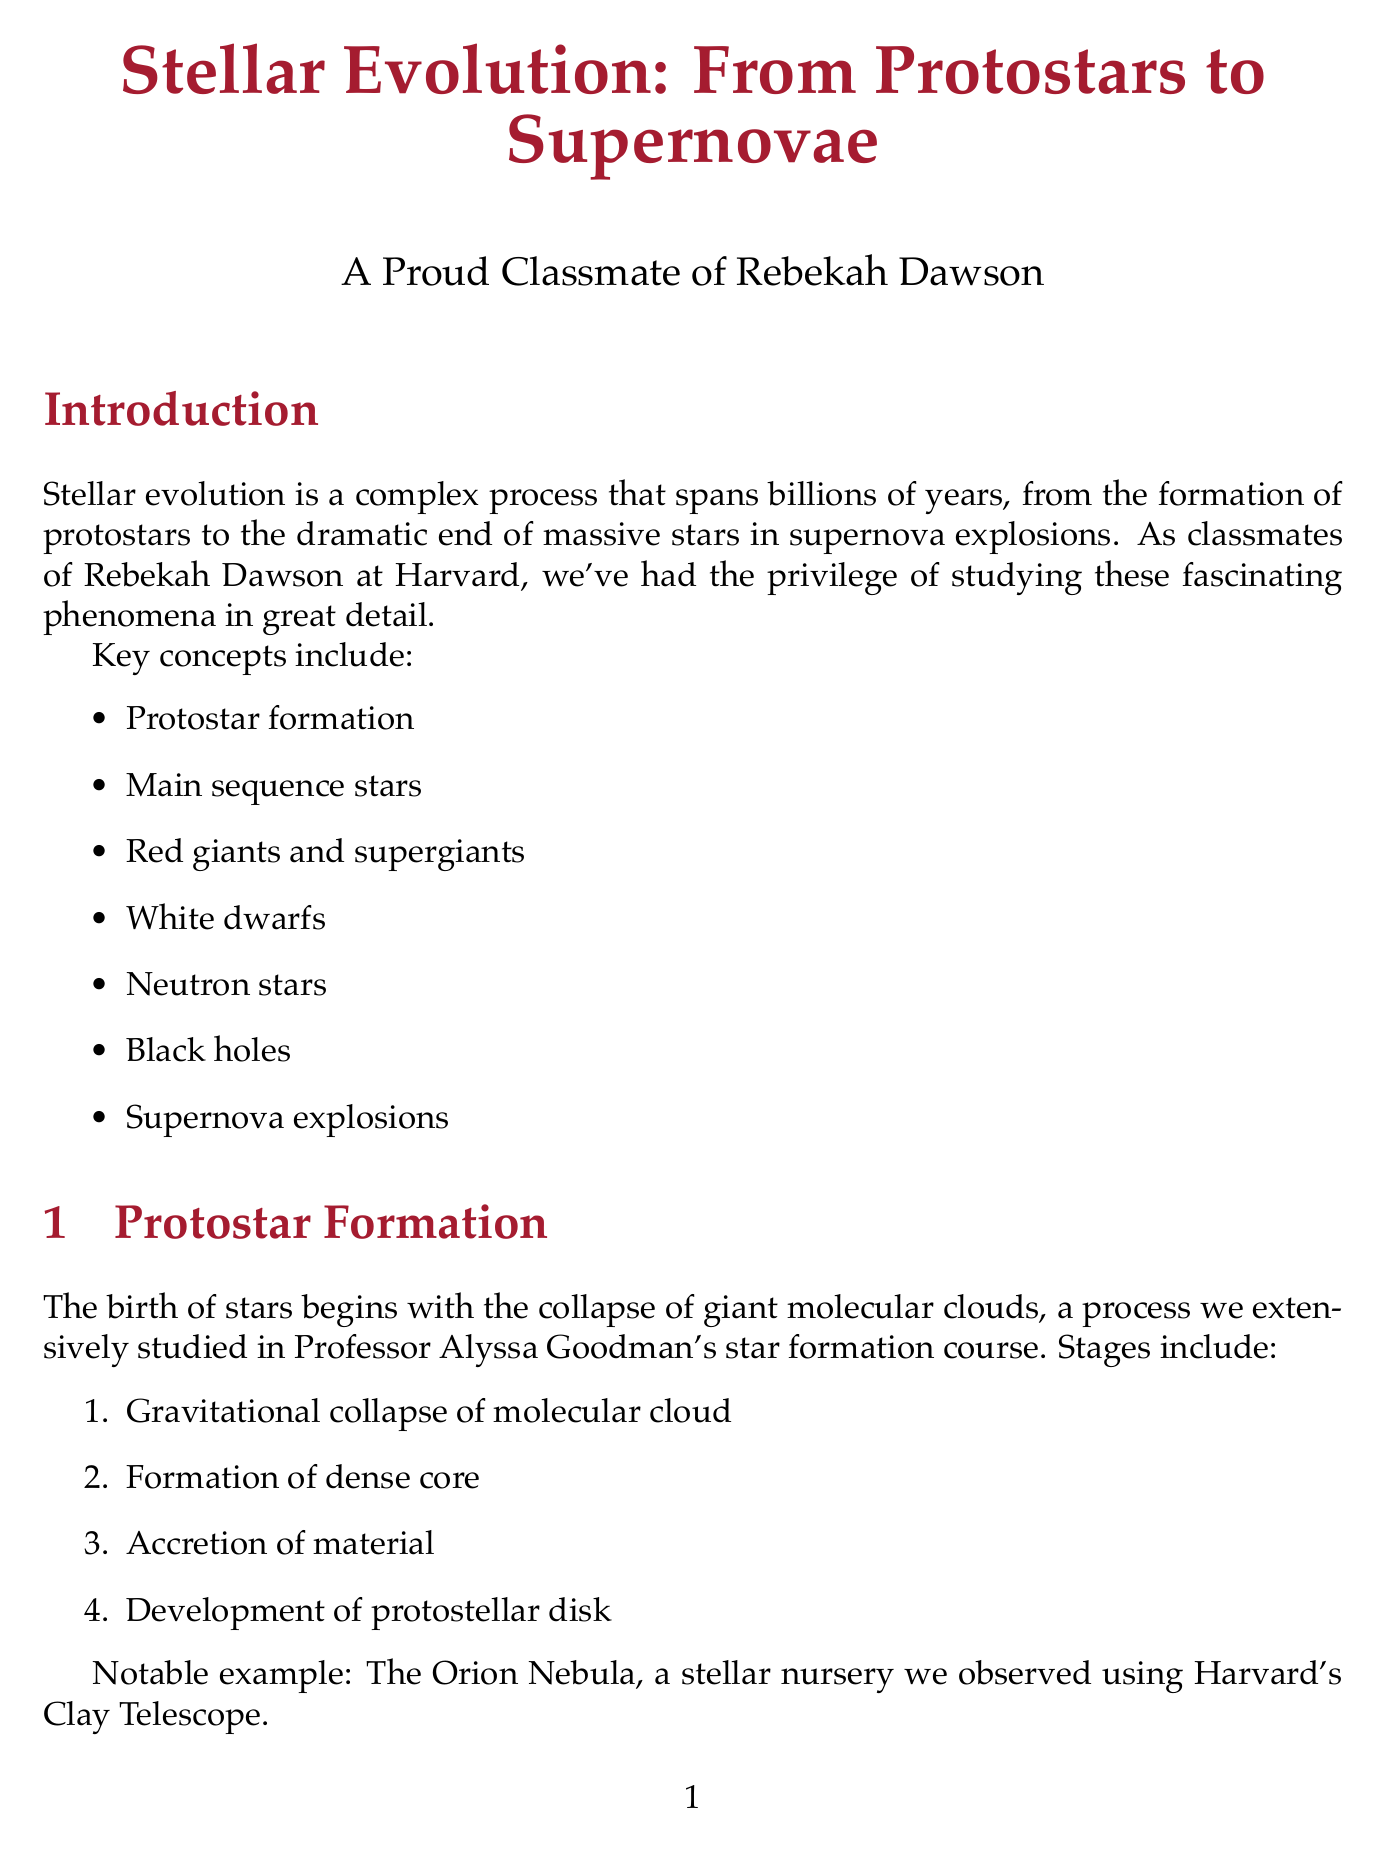What are the key concepts of stellar evolution? The document lists seven key concepts of stellar evolution, which include protostar formation, main sequence stars, red giants and supergiants, white dwarfs, neutron stars, black holes, and supernova explosions.
Answer: Protostar formation, main sequence stars, red giants and supergiants, white dwarfs, neutron stars, black holes, supernova explosions Who explained the red giant phase? The red giant phase was explained by Professor Dimitar Sasselov during his exoplanet course.
Answer: Professor Dimitar Sasselov What is the notable example of a protostar formation mentioned? The document provides the Orion Nebula as a notable example of a stellar nursery where protostar formation occurs.
Answer: The Orion Nebula What are the two types of supernova explosions outlined? The types of supernova explosions mentioned are Type Ia and Type II. These are key points within the supernova explosions section of the report.
Answer: Type Ia, Type II What are the properties of white dwarfs? The document outlines three properties of white dwarfs: electron degeneracy pressure, cooling over time, and the Chandrasekhar limit.
Answer: Electron degeneracy pressure, cooling over time, Chandrasekhar limit What diagram illustrates the stellar luminosity vs. temperature? The Hertzsprung-Russell Diagram is specifically mentioned as illustrating the plot of stellar luminosity vs. temperature.
Answer: Hertzsprung-Russell Diagram Which course did the analysis of main sequence stars use data from? The analysis of main sequence stars in the Pleiades cluster used data from the Harvard-Smithsonian Center for Astrophysics.
Answer: Harvard-Smithsonian Center for Astrophysics How were neutron stars covered in the document? The neutron stars section relates their formation and characteristics, as presented in Professor Ramesh Narayan's high-energy astrophysics lectures.
Answer: Professor Ramesh Narayan's high-energy astrophysics lectures What type of objects do low to intermediate-mass stars form after shedding their outer layers? After shedding their outer layers, low to intermediate-mass stars form planetary nebulae, which are described in the document.
Answer: Planetary nebulae 